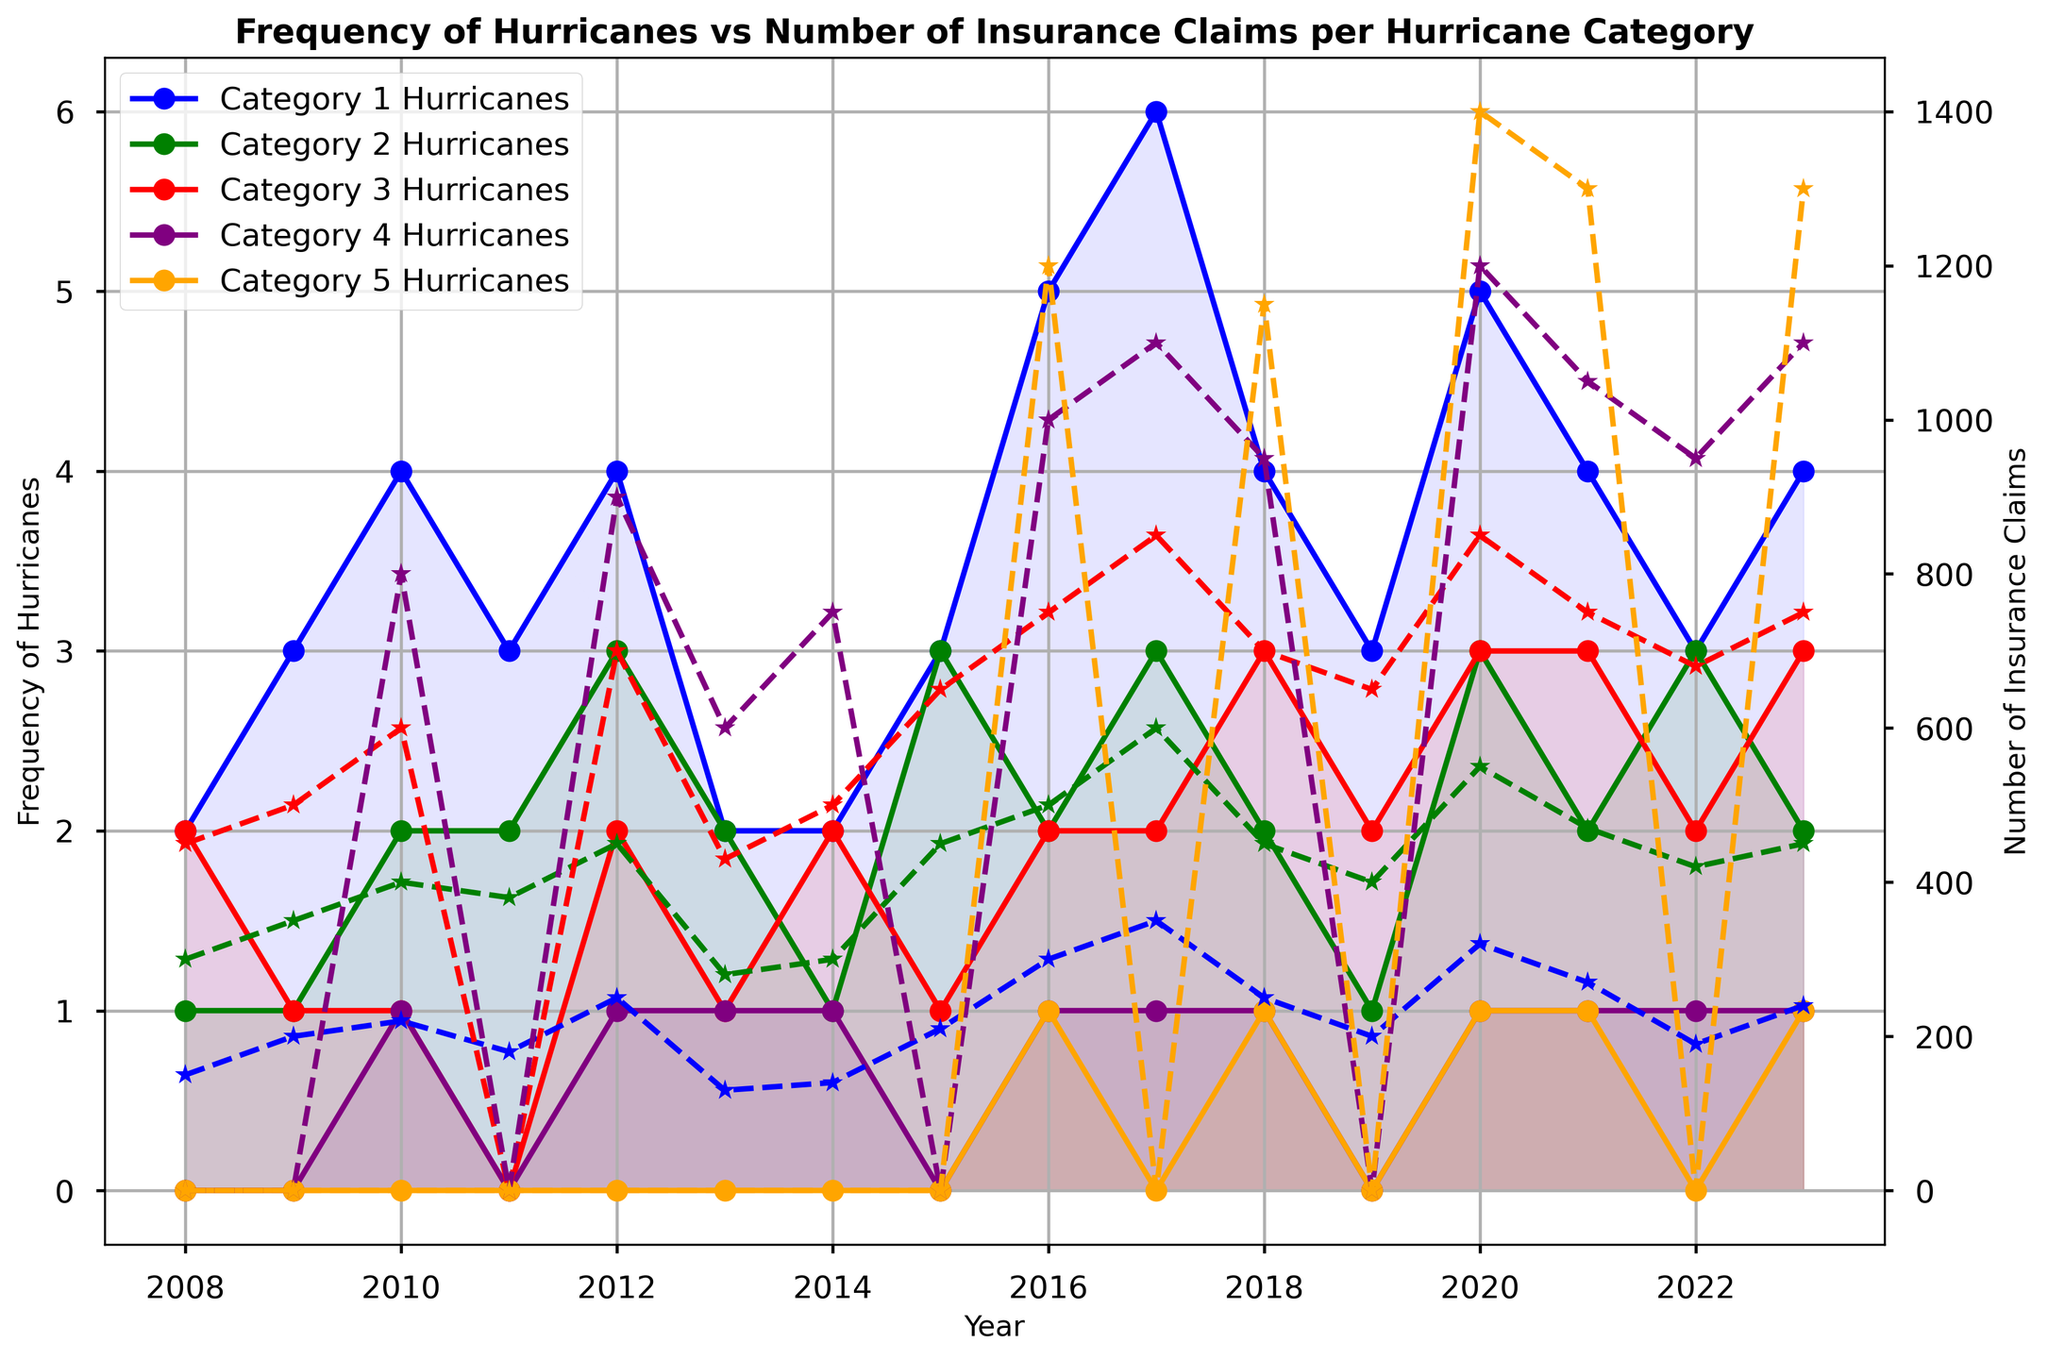What's the overall trend in the frequency of Category 1 hurricanes from 2008 to 2023? To determine the trend, look at the line representing Category 1 hurricanes and observe its movement over years. If it generally inclines, declines, or stays constant, it indicates the trend. From the plot, we can see an overall increase in the frequency of Category 1 hurricanes, especially notable towards the end of the period.
Answer: Increase How does the number of insurance claims for Category 5 hurricanes in 2020 compare to 2023? Find the lines and markers for the number of insurance claims for Category 5 in both years. Identify and compare the corresponding heights. In 2020, the number of insurance claims for Category 5 hurricanes is approximately 1,400, while in 2023, it is around 1,300.
Answer: 2020 is higher Which year experienced the highest frequency for Category 3 hurricanes, and what was the frequency? Follow the line representing Category 3 hurricanes, find the peak point and note the corresponding year and frequency. The highest frequency of Category 3 hurricanes is in 2018 and 2020, both with a frequency of 3 hurricanes.
Answer: 2018 and 2020, 3 hurricanes What is the difference in the number of insurance claims for Category 4 hurricanes between 2016 and 2021? Identify the number of insurance claims for Category 4 hurricanes in 2016 and 2021 from the respective data points. The values are approximately 1,000 for 2016 and 1,050 for 2021. The difference is 1,050 - 1,000.
Answer: 50 Comparing the frequency of hurricanes, which category showed the most variability over the years? Look at the fluctuations for each category line across the graph. The category with the most up-and-down movements has the most variability. Category 1 shows the most variability with frequent spikes and dips.
Answer: Category 1 What was the total number of Category 2 hurricanes between 2015 and 2020? Sum the frequencies of Category 2 hurricanes for each year from 2015 to 2020. The counts are 3 (2015) + 2 (2016) + 3 (2017) + 2 (2018) + 1 (2019) + 3 (2020). Thus, 3 + 2 + 3 + 2 + 1 + 3.
Answer: 14 In which year did Category 4 hurricanes first appear, and how frequent were they that year? Locate the first appearance point on the Category 4 hurricane line. They first appear in the year 2010, with a frequency of 1 hurricane.
Answer: 2010, 1 hurricane How does the frequency of Category 1 hurricanes in 2008 compare to the frequency in 2023? Identify the frequency on the Category 1 line for both years. The frequency in 2008 is 2 hurricanes, whereas in 2023, it is 4 hurricanes.
Answer: 2023 is higher Which category saw no hurricane activity in the year 2011? Find the year 2011 on the x-axis and observe which category lines are at zero. Category 3, 4, and 5 saw no hurricane activity in 2011.
Answer: Categories 3, 4, and 5 